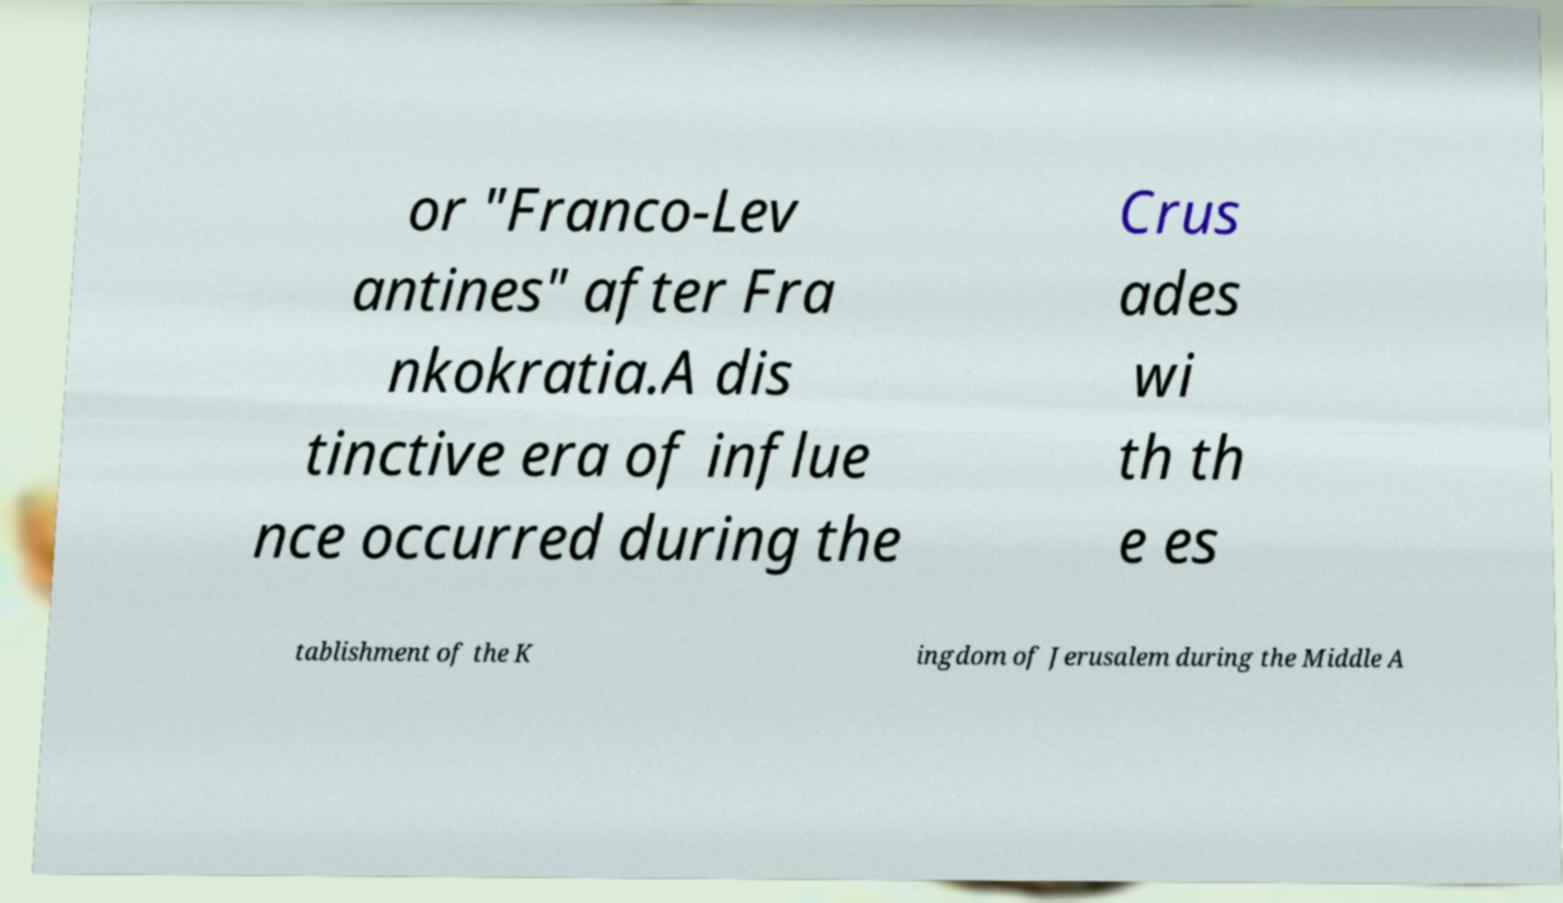Please read and relay the text visible in this image. What does it say? or "Franco-Lev antines" after Fra nkokratia.A dis tinctive era of influe nce occurred during the Crus ades wi th th e es tablishment of the K ingdom of Jerusalem during the Middle A 